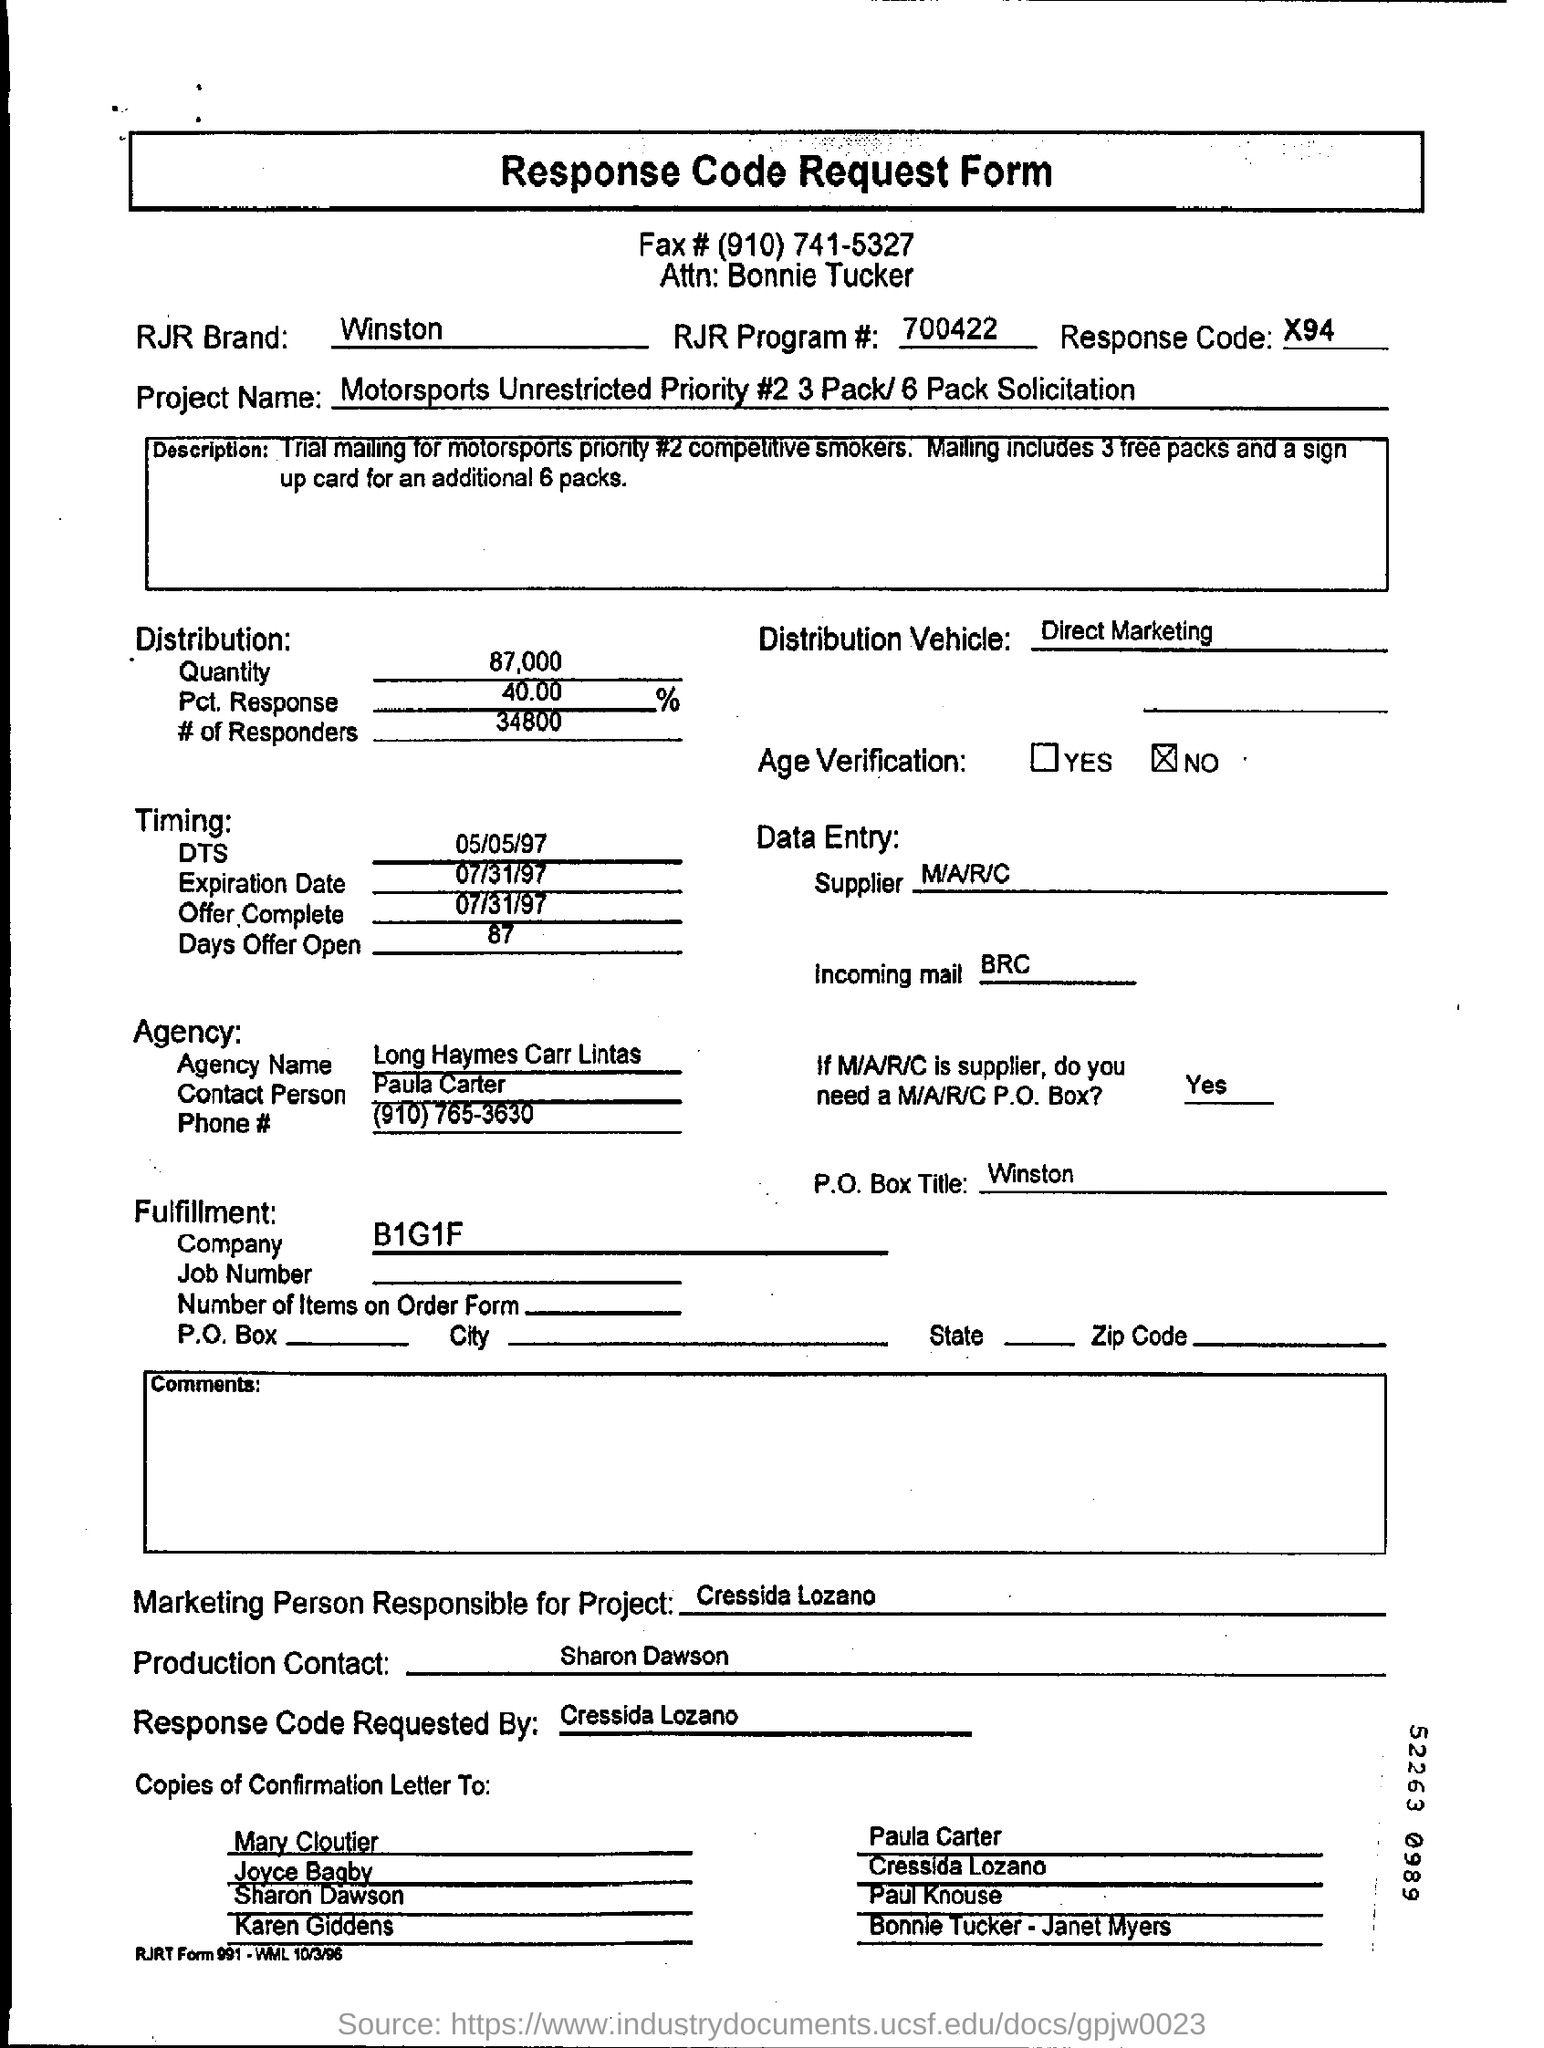Outline some significant characteristics in this image. I'm sorry, but I'm not sure what you're referring to. Could you please provide more context or clarify your question? The brand RJR mentioned is Winston. This form is requesting a response code regarding a response to a request. Long Haymes Carr Lintas is the name of the agency. Direct marketing involves the use of various distribution vehicles to deliver targeted advertisements to potential customers, with the aim of increasing brand awareness and driving sales. 